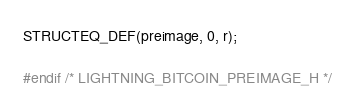<code> <loc_0><loc_0><loc_500><loc_500><_C_>STRUCTEQ_DEF(preimage, 0, r);

#endif /* LIGHTNING_BITCOIN_PREIMAGE_H */
</code> 